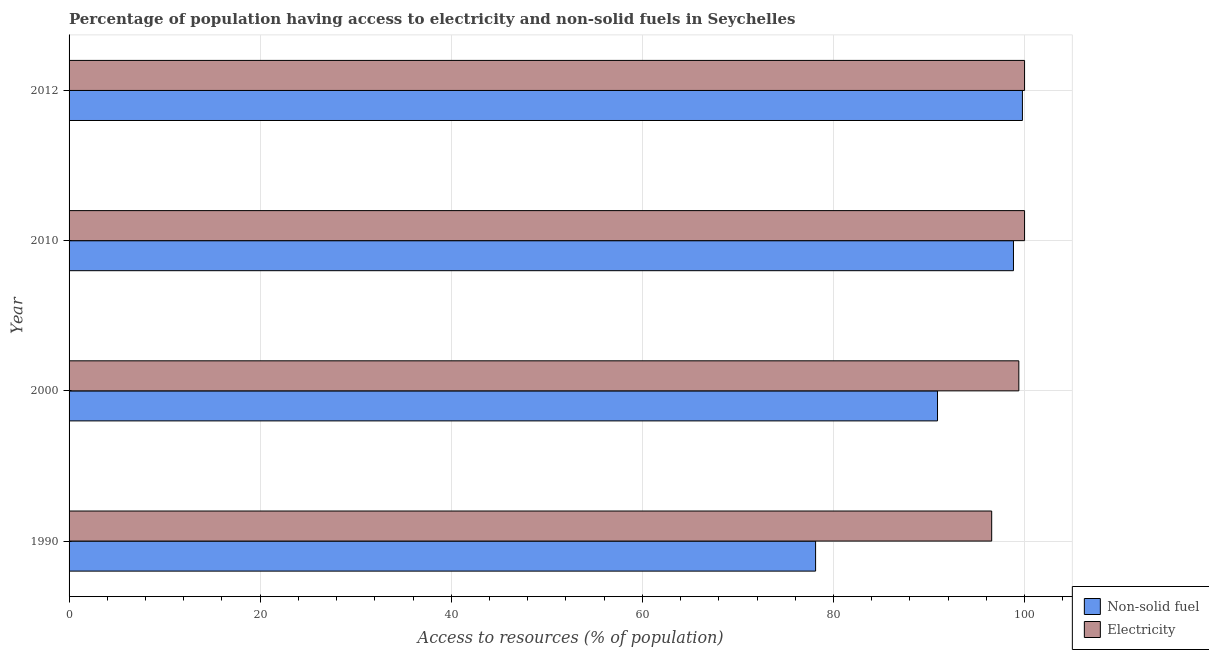How many groups of bars are there?
Keep it short and to the point. 4. How many bars are there on the 3rd tick from the top?
Keep it short and to the point. 2. How many bars are there on the 4th tick from the bottom?
Ensure brevity in your answer.  2. In how many cases, is the number of bars for a given year not equal to the number of legend labels?
Your answer should be very brief. 0. Across all years, what is the minimum percentage of population having access to electricity?
Give a very brief answer. 96.56. In which year was the percentage of population having access to electricity maximum?
Provide a succinct answer. 2010. In which year was the percentage of population having access to electricity minimum?
Offer a terse response. 1990. What is the total percentage of population having access to non-solid fuel in the graph?
Your answer should be very brief. 367.63. What is the difference between the percentage of population having access to electricity in 1990 and that in 2010?
Your response must be concise. -3.44. What is the difference between the percentage of population having access to non-solid fuel in 2000 and the percentage of population having access to electricity in 1990?
Give a very brief answer. -5.67. What is the average percentage of population having access to electricity per year?
Keep it short and to the point. 98.99. In the year 1990, what is the difference between the percentage of population having access to non-solid fuel and percentage of population having access to electricity?
Give a very brief answer. -18.43. What is the ratio of the percentage of population having access to non-solid fuel in 1990 to that in 2010?
Offer a terse response. 0.79. Is the percentage of population having access to non-solid fuel in 2000 less than that in 2012?
Give a very brief answer. Yes. Is the difference between the percentage of population having access to non-solid fuel in 2010 and 2012 greater than the difference between the percentage of population having access to electricity in 2010 and 2012?
Your answer should be compact. No. What is the difference between the highest and the second highest percentage of population having access to electricity?
Make the answer very short. 0. What is the difference between the highest and the lowest percentage of population having access to electricity?
Provide a succinct answer. 3.44. What does the 1st bar from the top in 1990 represents?
Offer a terse response. Electricity. What does the 1st bar from the bottom in 2012 represents?
Ensure brevity in your answer.  Non-solid fuel. How many bars are there?
Keep it short and to the point. 8. Are all the bars in the graph horizontal?
Offer a very short reply. Yes. What is the difference between two consecutive major ticks on the X-axis?
Ensure brevity in your answer.  20. Are the values on the major ticks of X-axis written in scientific E-notation?
Your answer should be very brief. No. Does the graph contain any zero values?
Your response must be concise. No. Does the graph contain grids?
Keep it short and to the point. Yes. How many legend labels are there?
Offer a terse response. 2. What is the title of the graph?
Give a very brief answer. Percentage of population having access to electricity and non-solid fuels in Seychelles. Does "Highest 10% of population" appear as one of the legend labels in the graph?
Offer a very short reply. No. What is the label or title of the X-axis?
Your answer should be compact. Access to resources (% of population). What is the label or title of the Y-axis?
Provide a succinct answer. Year. What is the Access to resources (% of population) of Non-solid fuel in 1990?
Your answer should be compact. 78.13. What is the Access to resources (% of population) in Electricity in 1990?
Give a very brief answer. 96.56. What is the Access to resources (% of population) in Non-solid fuel in 2000?
Offer a terse response. 90.89. What is the Access to resources (% of population) in Electricity in 2000?
Offer a very short reply. 99.4. What is the Access to resources (% of population) of Non-solid fuel in 2010?
Your answer should be compact. 98.84. What is the Access to resources (% of population) of Non-solid fuel in 2012?
Your response must be concise. 99.78. Across all years, what is the maximum Access to resources (% of population) in Non-solid fuel?
Your answer should be compact. 99.78. Across all years, what is the minimum Access to resources (% of population) in Non-solid fuel?
Provide a succinct answer. 78.13. Across all years, what is the minimum Access to resources (% of population) in Electricity?
Offer a very short reply. 96.56. What is the total Access to resources (% of population) of Non-solid fuel in the graph?
Keep it short and to the point. 367.63. What is the total Access to resources (% of population) of Electricity in the graph?
Keep it short and to the point. 395.96. What is the difference between the Access to resources (% of population) of Non-solid fuel in 1990 and that in 2000?
Your answer should be compact. -12.76. What is the difference between the Access to resources (% of population) in Electricity in 1990 and that in 2000?
Provide a short and direct response. -2.84. What is the difference between the Access to resources (% of population) of Non-solid fuel in 1990 and that in 2010?
Offer a terse response. -20.71. What is the difference between the Access to resources (% of population) of Electricity in 1990 and that in 2010?
Provide a succinct answer. -3.44. What is the difference between the Access to resources (% of population) in Non-solid fuel in 1990 and that in 2012?
Give a very brief answer. -21.65. What is the difference between the Access to resources (% of population) of Electricity in 1990 and that in 2012?
Ensure brevity in your answer.  -3.44. What is the difference between the Access to resources (% of population) of Non-solid fuel in 2000 and that in 2010?
Your answer should be compact. -7.95. What is the difference between the Access to resources (% of population) in Non-solid fuel in 2000 and that in 2012?
Ensure brevity in your answer.  -8.89. What is the difference between the Access to resources (% of population) of Electricity in 2000 and that in 2012?
Give a very brief answer. -0.6. What is the difference between the Access to resources (% of population) in Non-solid fuel in 2010 and that in 2012?
Make the answer very short. -0.94. What is the difference between the Access to resources (% of population) of Electricity in 2010 and that in 2012?
Provide a short and direct response. 0. What is the difference between the Access to resources (% of population) of Non-solid fuel in 1990 and the Access to resources (% of population) of Electricity in 2000?
Provide a succinct answer. -21.27. What is the difference between the Access to resources (% of population) in Non-solid fuel in 1990 and the Access to resources (% of population) in Electricity in 2010?
Your answer should be compact. -21.87. What is the difference between the Access to resources (% of population) of Non-solid fuel in 1990 and the Access to resources (% of population) of Electricity in 2012?
Give a very brief answer. -21.87. What is the difference between the Access to resources (% of population) in Non-solid fuel in 2000 and the Access to resources (% of population) in Electricity in 2010?
Keep it short and to the point. -9.11. What is the difference between the Access to resources (% of population) of Non-solid fuel in 2000 and the Access to resources (% of population) of Electricity in 2012?
Offer a terse response. -9.11. What is the difference between the Access to resources (% of population) of Non-solid fuel in 2010 and the Access to resources (% of population) of Electricity in 2012?
Your answer should be compact. -1.16. What is the average Access to resources (% of population) of Non-solid fuel per year?
Provide a succinct answer. 91.91. What is the average Access to resources (% of population) of Electricity per year?
Give a very brief answer. 98.99. In the year 1990, what is the difference between the Access to resources (% of population) of Non-solid fuel and Access to resources (% of population) of Electricity?
Give a very brief answer. -18.43. In the year 2000, what is the difference between the Access to resources (% of population) of Non-solid fuel and Access to resources (% of population) of Electricity?
Provide a short and direct response. -8.51. In the year 2010, what is the difference between the Access to resources (% of population) in Non-solid fuel and Access to resources (% of population) in Electricity?
Your response must be concise. -1.16. In the year 2012, what is the difference between the Access to resources (% of population) of Non-solid fuel and Access to resources (% of population) of Electricity?
Your answer should be very brief. -0.22. What is the ratio of the Access to resources (% of population) in Non-solid fuel in 1990 to that in 2000?
Offer a terse response. 0.86. What is the ratio of the Access to resources (% of population) in Electricity in 1990 to that in 2000?
Ensure brevity in your answer.  0.97. What is the ratio of the Access to resources (% of population) of Non-solid fuel in 1990 to that in 2010?
Your response must be concise. 0.79. What is the ratio of the Access to resources (% of population) in Electricity in 1990 to that in 2010?
Make the answer very short. 0.97. What is the ratio of the Access to resources (% of population) in Non-solid fuel in 1990 to that in 2012?
Your answer should be very brief. 0.78. What is the ratio of the Access to resources (% of population) in Electricity in 1990 to that in 2012?
Offer a terse response. 0.97. What is the ratio of the Access to resources (% of population) in Non-solid fuel in 2000 to that in 2010?
Offer a very short reply. 0.92. What is the ratio of the Access to resources (% of population) of Electricity in 2000 to that in 2010?
Your answer should be very brief. 0.99. What is the ratio of the Access to resources (% of population) of Non-solid fuel in 2000 to that in 2012?
Your answer should be very brief. 0.91. What is the ratio of the Access to resources (% of population) in Non-solid fuel in 2010 to that in 2012?
Your response must be concise. 0.99. What is the difference between the highest and the second highest Access to resources (% of population) in Non-solid fuel?
Your answer should be compact. 0.94. What is the difference between the highest and the second highest Access to resources (% of population) of Electricity?
Provide a short and direct response. 0. What is the difference between the highest and the lowest Access to resources (% of population) in Non-solid fuel?
Your response must be concise. 21.65. What is the difference between the highest and the lowest Access to resources (% of population) in Electricity?
Your response must be concise. 3.44. 